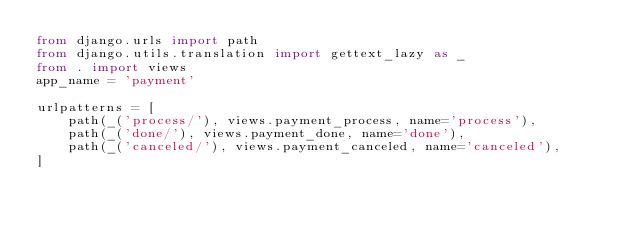Convert code to text. <code><loc_0><loc_0><loc_500><loc_500><_Python_>from django.urls import path
from django.utils.translation import gettext_lazy as _
from . import views
app_name = 'payment'

urlpatterns = [
    path(_('process/'), views.payment_process, name='process'),
    path(_('done/'), views.payment_done, name='done'),
    path(_('canceled/'), views.payment_canceled, name='canceled'),
]
</code> 